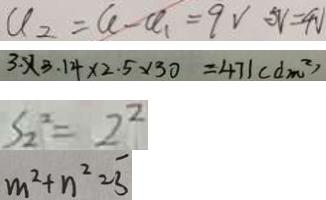Convert formula to latex. <formula><loc_0><loc_0><loc_500><loc_500>a _ { 2 } = a - a _ { 1 } = 9 V 5 V = 4 V 
 3 \times 3 . 1 4 \times 2 . 5 \times 3 0 = 4 7 1 ( d m ^ { 2 } ) 
 S _ { 2 } ^ { 2 } = 2 ^ { 2 } 
 m ^ { 2 } + n ^ { 2 } = \overline { 3 }</formula> 